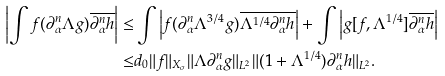<formula> <loc_0><loc_0><loc_500><loc_500>\left | \int f ( \partial _ { \alpha } ^ { n } \Lambda g ) \overline { \partial _ { \alpha } ^ { n } h } \right | \leq & \int \left | f ( \partial _ { \alpha } ^ { n } \Lambda ^ { 3 / 4 } g ) \overline { \Lambda ^ { 1 / 4 } \partial _ { \alpha } ^ { n } h } \right | + \int \left | g [ f , \Lambda ^ { 1 / 4 } ] \overline { \partial _ { \alpha } ^ { n } h } \right | \\ \leq & d _ { 0 } \| f \| _ { X _ { \sigma } } \| \Lambda \partial _ { \alpha } ^ { n } g \| _ { L ^ { 2 } } \| ( 1 + \Lambda ^ { 1 / 4 } ) \partial _ { \alpha } ^ { n } h \| _ { L ^ { 2 } } .</formula> 